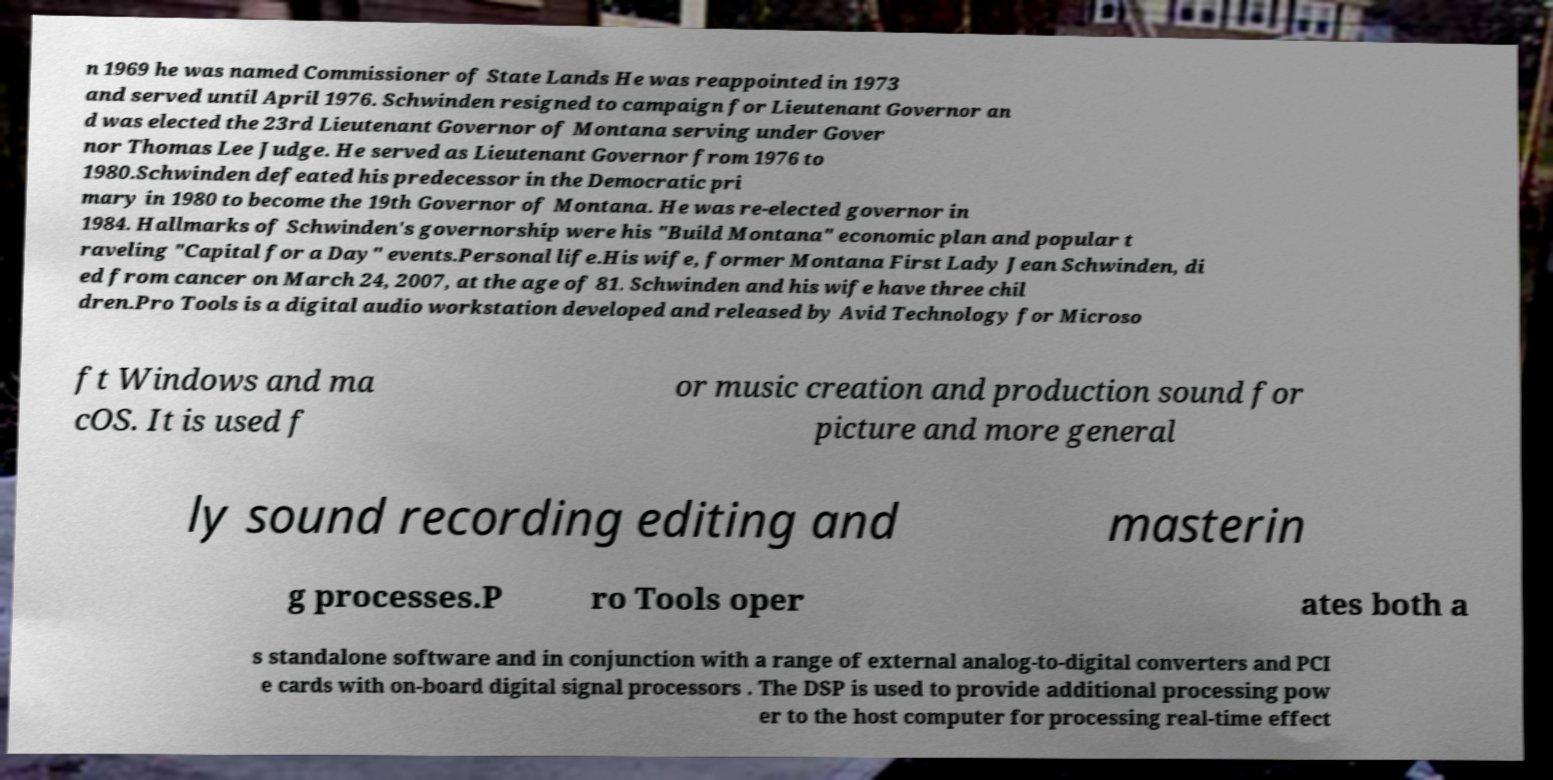For documentation purposes, I need the text within this image transcribed. Could you provide that? n 1969 he was named Commissioner of State Lands He was reappointed in 1973 and served until April 1976. Schwinden resigned to campaign for Lieutenant Governor an d was elected the 23rd Lieutenant Governor of Montana serving under Gover nor Thomas Lee Judge. He served as Lieutenant Governor from 1976 to 1980.Schwinden defeated his predecessor in the Democratic pri mary in 1980 to become the 19th Governor of Montana. He was re-elected governor in 1984. Hallmarks of Schwinden's governorship were his "Build Montana" economic plan and popular t raveling "Capital for a Day" events.Personal life.His wife, former Montana First Lady Jean Schwinden, di ed from cancer on March 24, 2007, at the age of 81. Schwinden and his wife have three chil dren.Pro Tools is a digital audio workstation developed and released by Avid Technology for Microso ft Windows and ma cOS. It is used f or music creation and production sound for picture and more general ly sound recording editing and masterin g processes.P ro Tools oper ates both a s standalone software and in conjunction with a range of external analog-to-digital converters and PCI e cards with on-board digital signal processors . The DSP is used to provide additional processing pow er to the host computer for processing real-time effect 